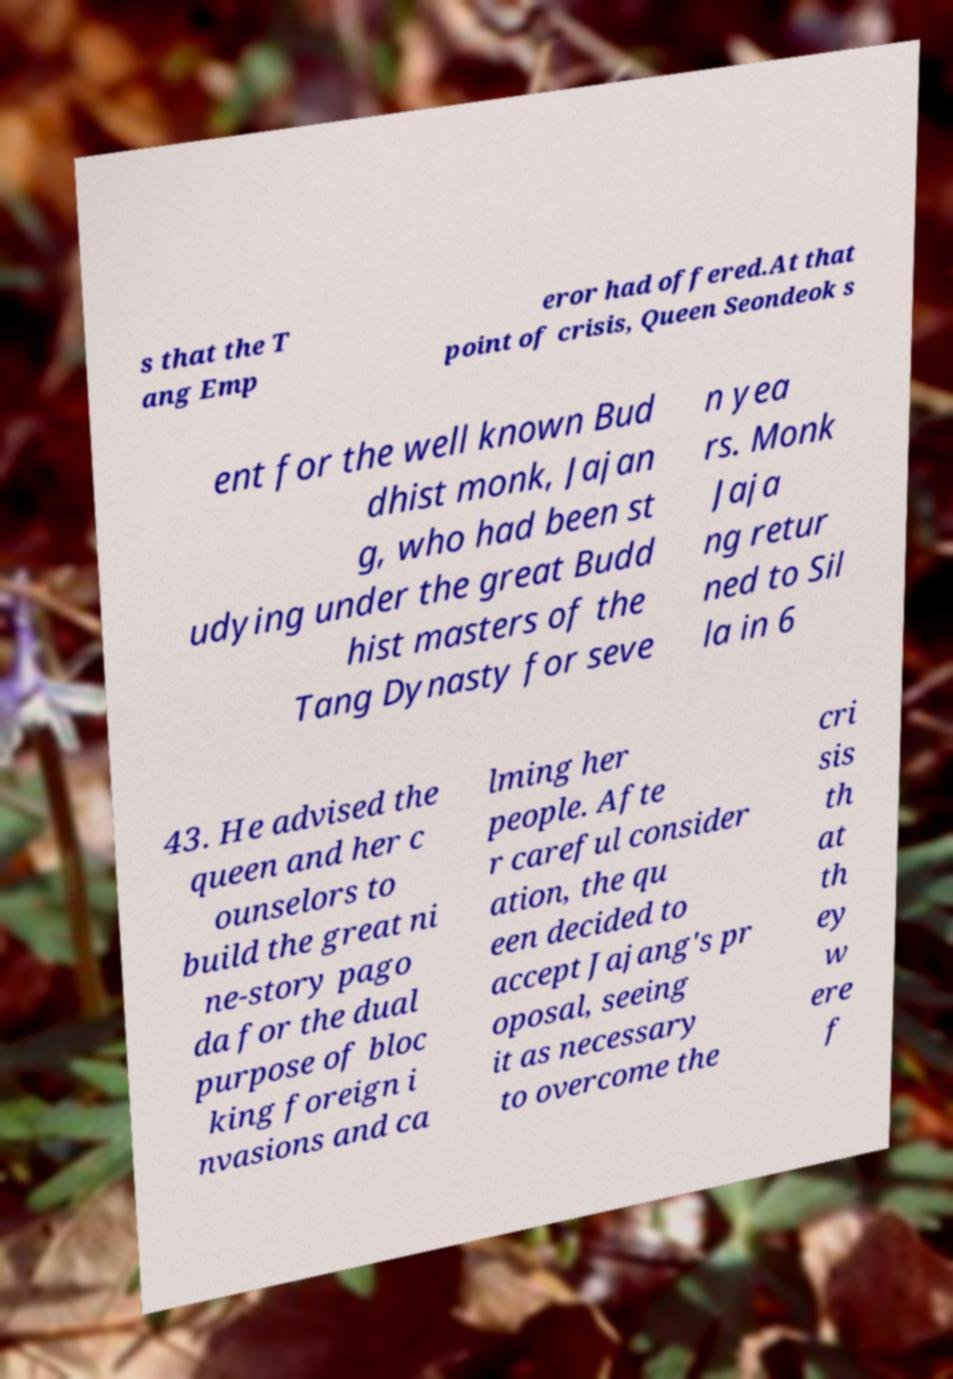For documentation purposes, I need the text within this image transcribed. Could you provide that? s that the T ang Emp eror had offered.At that point of crisis, Queen Seondeok s ent for the well known Bud dhist monk, Jajan g, who had been st udying under the great Budd hist masters of the Tang Dynasty for seve n yea rs. Monk Jaja ng retur ned to Sil la in 6 43. He advised the queen and her c ounselors to build the great ni ne-story pago da for the dual purpose of bloc king foreign i nvasions and ca lming her people. Afte r careful consider ation, the qu een decided to accept Jajang's pr oposal, seeing it as necessary to overcome the cri sis th at th ey w ere f 